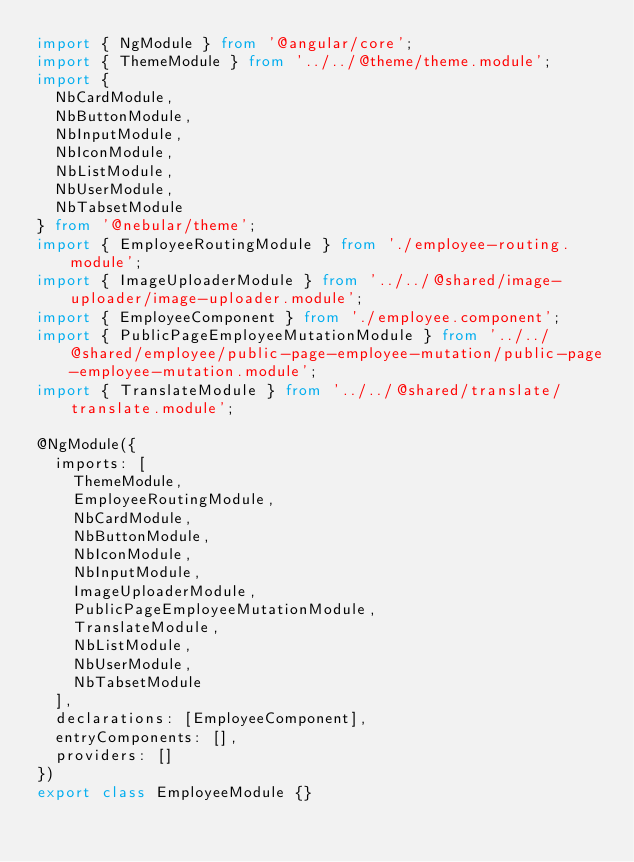<code> <loc_0><loc_0><loc_500><loc_500><_TypeScript_>import { NgModule } from '@angular/core';
import { ThemeModule } from '../../@theme/theme.module';
import {
	NbCardModule,
	NbButtonModule,
	NbInputModule,
	NbIconModule,
	NbListModule,
	NbUserModule,
	NbTabsetModule
} from '@nebular/theme';
import { EmployeeRoutingModule } from './employee-routing.module';
import { ImageUploaderModule } from '../../@shared/image-uploader/image-uploader.module';
import { EmployeeComponent } from './employee.component';
import { PublicPageEmployeeMutationModule } from '../../@shared/employee/public-page-employee-mutation/public-page-employee-mutation.module';
import { TranslateModule } from '../../@shared/translate/translate.module';

@NgModule({
	imports: [
		ThemeModule,
		EmployeeRoutingModule,
		NbCardModule,
		NbButtonModule,
		NbIconModule,
		NbInputModule,
		ImageUploaderModule,
		PublicPageEmployeeMutationModule,
		TranslateModule,
		NbListModule,
		NbUserModule,
		NbTabsetModule
	],
	declarations: [EmployeeComponent],
	entryComponents: [],
	providers: []
})
export class EmployeeModule {}
</code> 